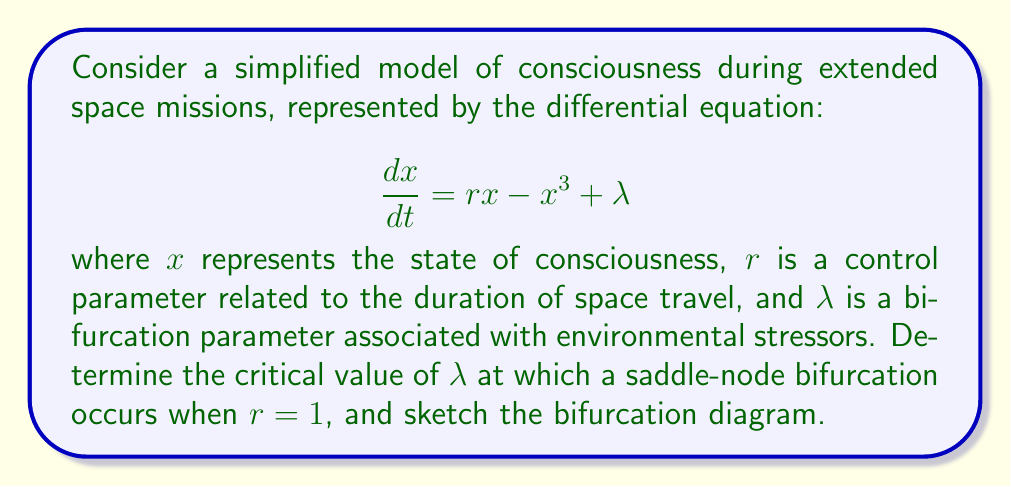Provide a solution to this math problem. 1) To find the equilibrium points, set $\frac{dx}{dt} = 0$:

   $$rx - x^3 + \lambda = 0$$

2) With $r = 1$, we have:

   $$x - x^3 + \lambda = 0$$

3) Rearrange to standard cubic form:

   $$x^3 - x - \lambda = 0$$

4) At the saddle-node bifurcation, this equation has a double root. This occurs when the discriminant of the cubic equation is zero.

5) The discriminant for a cubic equation $ax^3 + bx^2 + cx + d = 0$ is:

   $$\Delta = 18abcd - 4b^3d + b^2c^2 - 4ac^3 - 27a^2d^2$$

6) In our case, $a=1$, $b=0$, $c=-1$, and $d=-\lambda$. Substituting:

   $$\Delta = -4(-1)^3 - 27(1)^2(-\lambda)^2 = -4 - 27\lambda^2$$

7) Set the discriminant to zero:

   $$-4 - 27\lambda^2 = 0$$

8) Solve for $\lambda$:

   $$27\lambda^2 = -4$$
   $$\lambda^2 = -\frac{4}{27}$$
   $$\lambda = \pm\frac{2}{3\sqrt{3}}$$

9) The bifurcation diagram will show a parabola-like curve opening to the right, with the turning point at $(\lambda, x) = (\frac{2}{3\sqrt{3}}, \frac{1}{\sqrt{3}})$ for the positive solution.

[asy]
size(200,200);
import graph;

real f(real x) {return x - x^3;}

draw(graph(f,-1.5,1.5));
draw((-.4,-1.3) -- (0.4,-1.3),arrow=Arrow(TeXHead));
draw((-1.5,0.385) -- (-1.5,-0.385),arrow=Arrow(TeXHead));

label("$\lambda$",(0.4,-1.3),E);
label("$x$",(-1.5,0.385),N);
label("$\frac{2}{3\sqrt{3}}$",(0.385,-1.3),S);
label("$\frac{1}{\sqrt{3}}$",(-1.5,0.577),W);

dot((0.385,0.577));
[/asy]
Answer: $\lambda = \pm\frac{2}{3\sqrt{3}}$ 